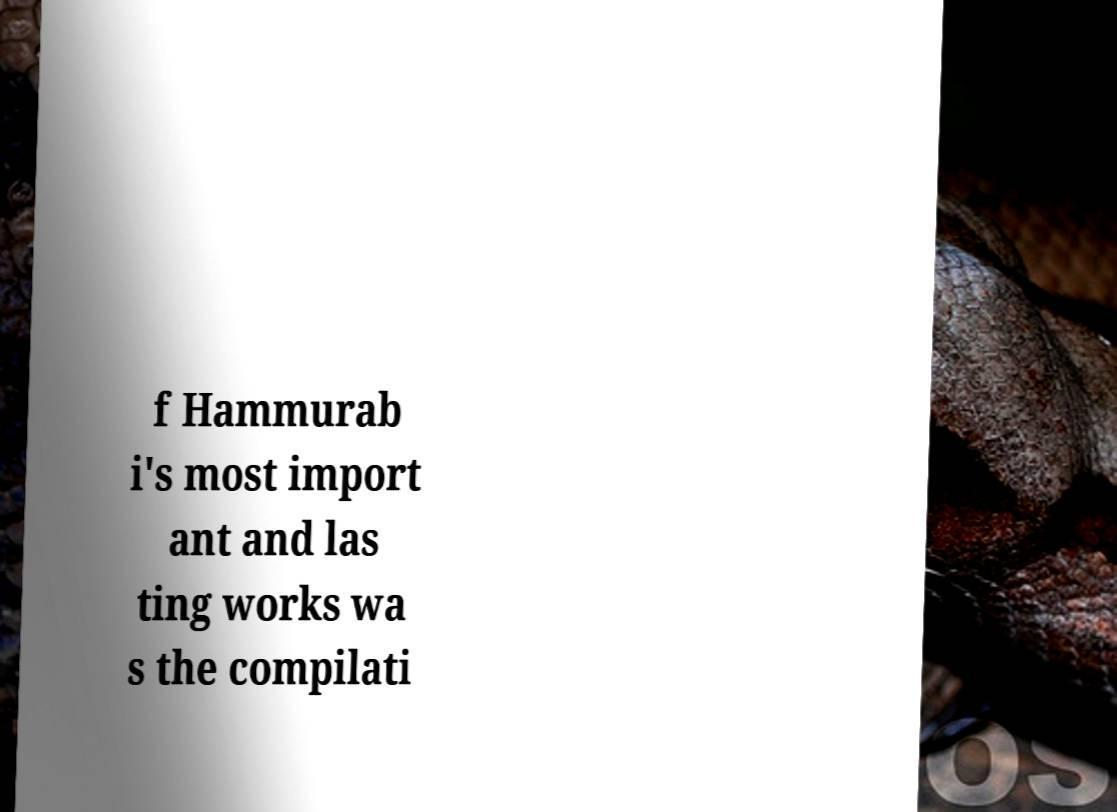Please read and relay the text visible in this image. What does it say? f Hammurab i's most import ant and las ting works wa s the compilati 